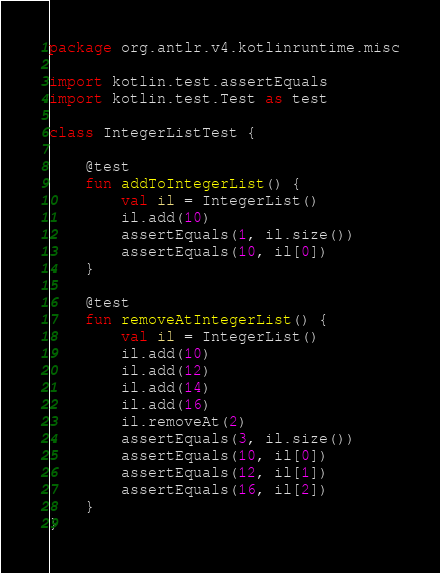Convert code to text. <code><loc_0><loc_0><loc_500><loc_500><_Kotlin_>package org.antlr.v4.kotlinruntime.misc

import kotlin.test.assertEquals
import kotlin.test.Test as test

class IntegerListTest {

    @test
    fun addToIntegerList() {
        val il = IntegerList()
        il.add(10)
        assertEquals(1, il.size())
        assertEquals(10, il[0])
    }

    @test
    fun removeAtIntegerList() {
        val il = IntegerList()
        il.add(10)
        il.add(12)
        il.add(14)
        il.add(16)
        il.removeAt(2)
        assertEquals(3, il.size())
        assertEquals(10, il[0])
        assertEquals(12, il[1])
        assertEquals(16, il[2])
    }
}
</code> 